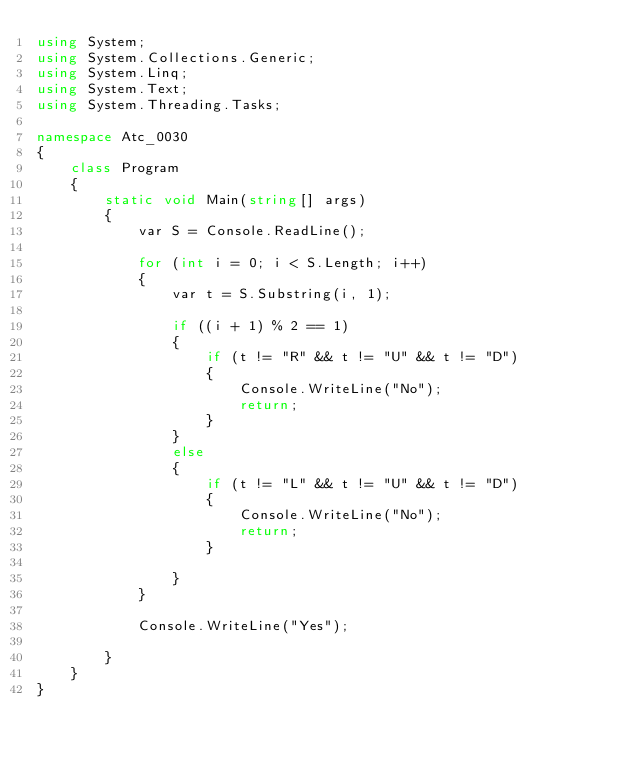Convert code to text. <code><loc_0><loc_0><loc_500><loc_500><_C#_>using System;
using System.Collections.Generic;
using System.Linq;
using System.Text;
using System.Threading.Tasks;

namespace Atc_0030
{
    class Program
    {
        static void Main(string[] args)
        {
            var S = Console.ReadLine();

            for (int i = 0; i < S.Length; i++)
            {
                var t = S.Substring(i, 1);

                if ((i + 1) % 2 == 1)
                {
                    if (t != "R" && t != "U" && t != "D")
                    {
                        Console.WriteLine("No");
                        return;
                    }
                }
                else
                {
                    if (t != "L" && t != "U" && t != "D")
                    {
                        Console.WriteLine("No");
                        return;
                    }

                }   
            }

            Console.WriteLine("Yes");

        }
    }
}
</code> 